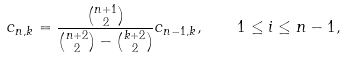Convert formula to latex. <formula><loc_0><loc_0><loc_500><loc_500>c _ { n , k } = \frac { \binom { n + 1 } { 2 } } { \binom { n + 2 } { 2 } - \binom { k + 2 } { 2 } } c _ { n - 1 , k } , \quad 1 \leq i \leq n - 1 ,</formula> 